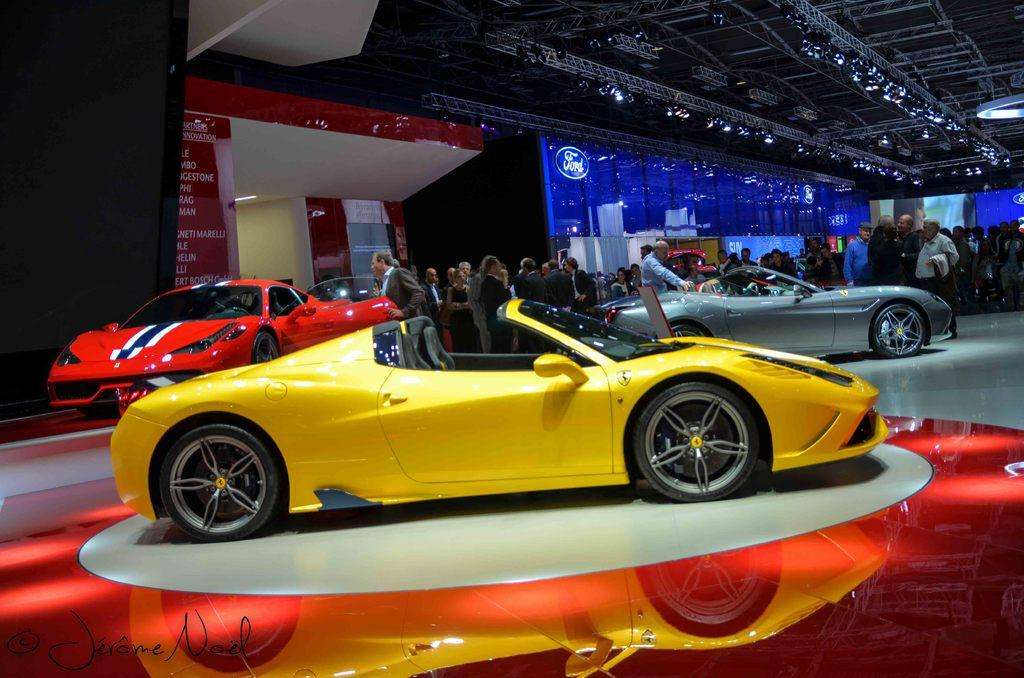What type of vehicles can be seen in the image? There are cars in the image. Are there any people present in the image? Yes, there are persons in the image. What additional objects can be seen in the image? There are banners in the image. Where is one of the banners located? There is a banner on the left side of the image. What can be observed about the text on the banner? The text on the banner is red in color. Reasoning: Let's think step by step by step in order to produce the conversation. We start by identifying the main subjects and objects in the image based on the provided facts. We then formulate questions that focus on the location and characteristics of these subjects and objects, ensuring that each question can be answered definitively with the information given. We avoid yes/no questions and ensure that the language is simple and clear. Absurd Question/Answer: Can you describe the fairies flying around the cars in the image? There are no fairies present in the image; it only features cars, persons, and banners. What color is the orange on the right side of the image? There is no orange present in the image. Can you describe the fairies flying around the cars in the image? There are no fairies present in the image; it only features cars, persons, and banners. What color is the orange on the right side of the image? There is no orange present in the image. 